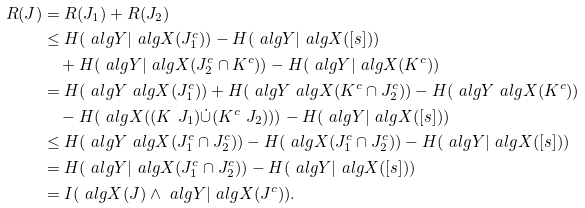<formula> <loc_0><loc_0><loc_500><loc_500>R ( J ) & = R ( J _ { 1 } ) + R ( J _ { 2 } ) \\ & \leq H ( \ a l g { Y } | \ a l g { X } ( J _ { 1 } ^ { c } ) ) - H ( \ a l g { Y } | \ a l g { X } ( [ s ] ) ) \\ & \quad + H ( \ a l g { Y } | \ a l g { X } ( J _ { 2 } ^ { c } \cap K ^ { c } ) ) - H ( \ a l g { Y } | \ a l g { X } ( K ^ { c } ) ) \\ & = H ( \ a l g { Y } \ a l g { X } ( J _ { 1 } ^ { c } ) ) + H ( \ a l g { Y } \ a l g { X } ( K ^ { c } \cap J _ { 2 } ^ { c } ) ) - H ( \ a l g { Y } \ a l g { X } ( K ^ { c } ) ) \\ & \quad - H ( \ a l g { X } ( ( K \ J _ { 1 } ) \dot { \cup } ( K ^ { c } \ J _ { 2 } ) ) ) - H ( \ a l g { Y } | \ a l g { X } ( [ s ] ) ) \\ & \leq H ( \ a l g { Y } \ a l g { X } ( J _ { 1 } ^ { c } \cap J _ { 2 } ^ { c } ) ) - H ( \ a l g { X } ( J _ { 1 } ^ { c } \cap J _ { 2 } ^ { c } ) ) - H ( \ a l g { Y } | \ a l g { X } ( [ s ] ) ) \\ & = H ( \ a l g { Y } | \ a l g { X } ( J _ { 1 } ^ { c } \cap J _ { 2 } ^ { c } ) ) - H ( \ a l g { Y } | \ a l g { X } ( [ s ] ) ) \\ & = I ( \ a l g { X } ( J ) \wedge \ a l g { Y } | \ a l g { X } ( J ^ { c } ) ) .</formula> 